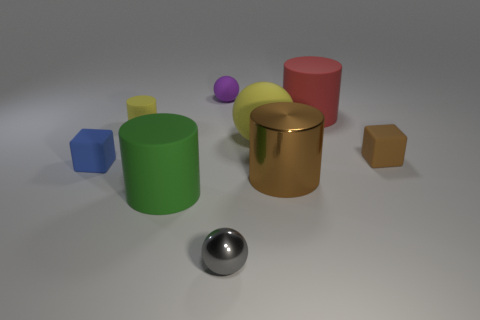There is a large metal thing; does it have the same color as the tiny ball that is behind the large green matte thing? The large metal object has a reflective silver color, while the small ball behind the large green cylinder has a distinct purple hue. Therefore, they do not share the same color. 